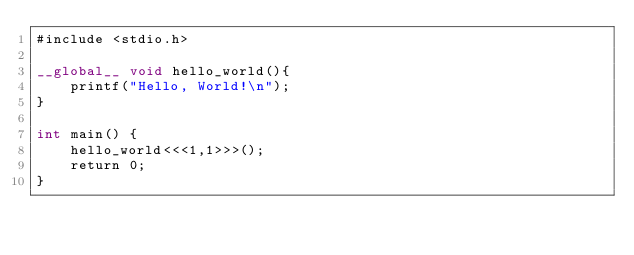Convert code to text. <code><loc_0><loc_0><loc_500><loc_500><_Cuda_>#include <stdio.h>

__global__ void hello_world(){
    printf("Hello, World!\n");
}

int main() {
    hello_world<<<1,1>>>();
    return 0;
}
</code> 